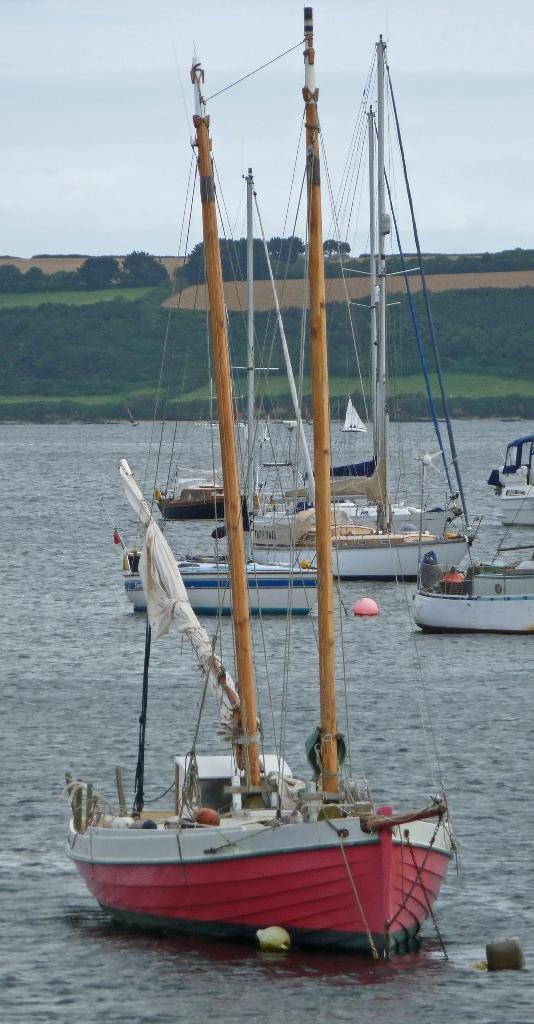What can be seen in the image that is used for transportation on water? There are boats in the image. What is the primary element in which the boats are situated? There is water visible in the image. What type of vegetation can be seen in the background of the image? There are trees in the background of the image. What other natural elements can be seen in the background of the image? There is grass in the background of the image. What is visible at the top of the image? The sky is visible at the top of the image. What type of toothpaste is being used to clean the boats in the image? There is no toothpaste present in the image, and the boats are not being cleaned. 